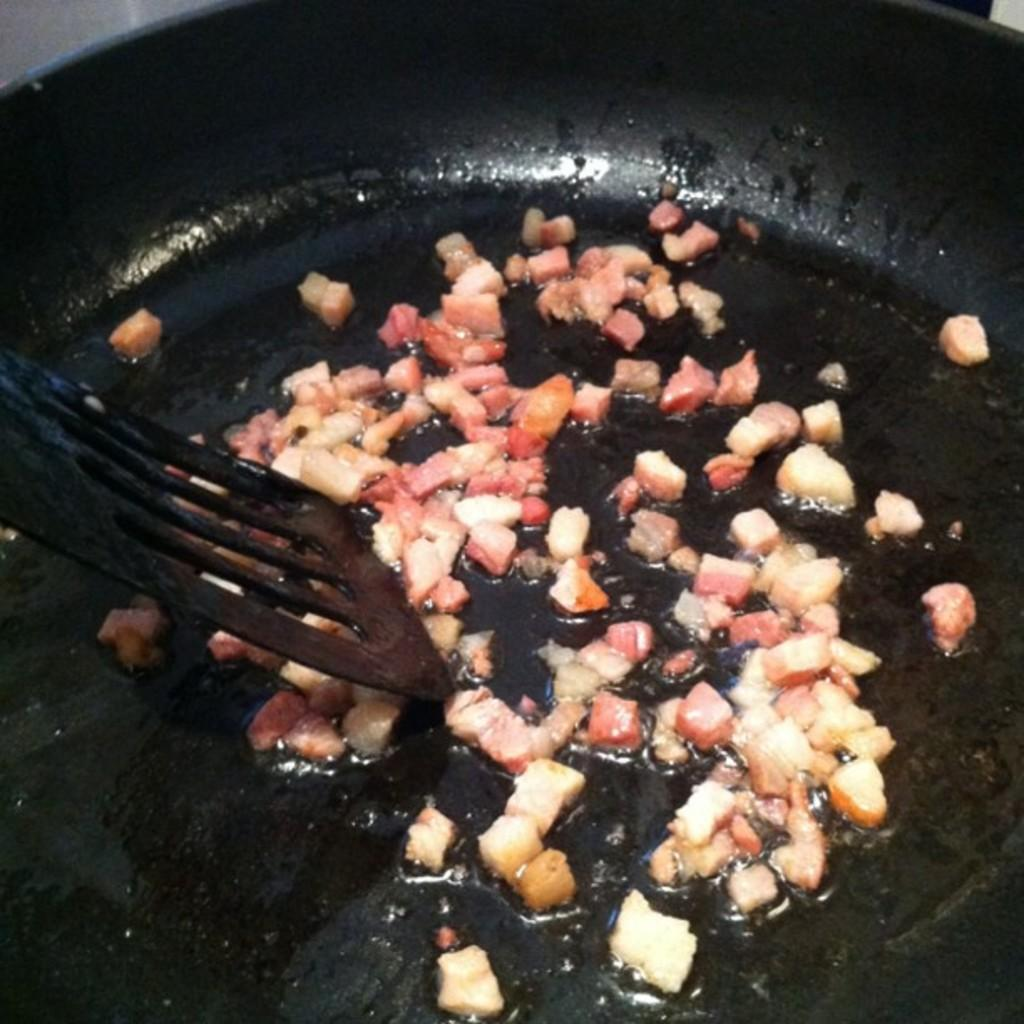What is the main object in the image? There is a frying pan in the image. What color is the frying pan? The frying pan is black in color. What other object can be seen in the image? There is an utensil in the image. What color is the utensil? The utensil is black in color. What else is visible in the image? There are pieces of food in the image. What colors are the pieces of food? The pieces of food are white and red in color. What type of gold object can be seen in the image? There is no gold object present in the image. What letters are visible on the frying pan in the image? There are no letters visible on the frying pan in the image. 